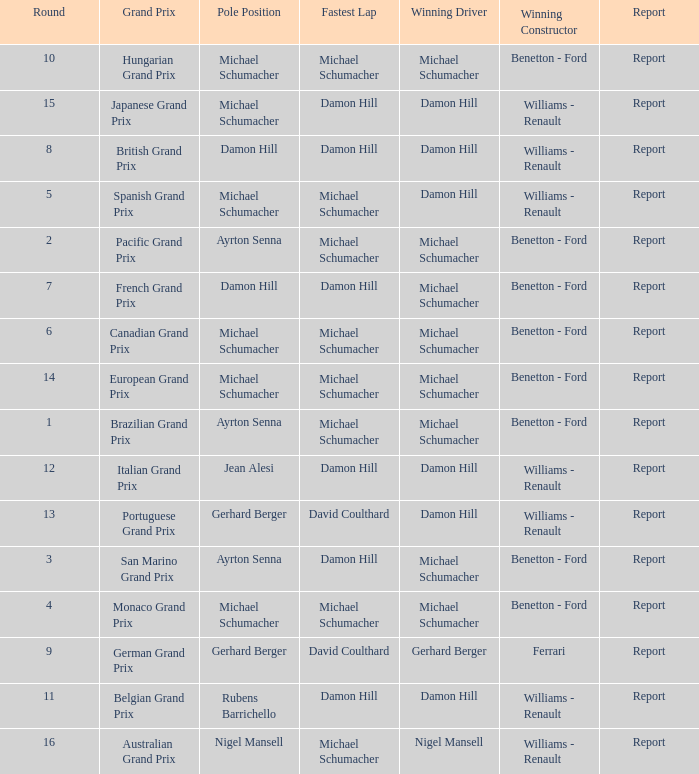Name the fastest lap for the brazilian grand prix Michael Schumacher. 